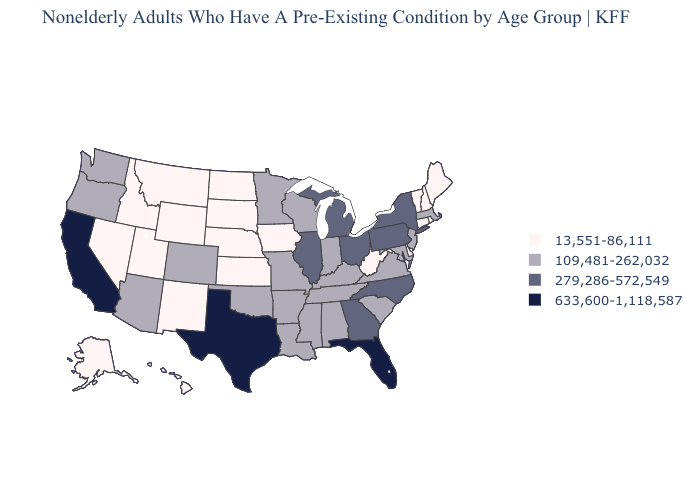Does Pennsylvania have the highest value in the Northeast?
Quick response, please. Yes. Does California have the lowest value in the West?
Answer briefly. No. Name the states that have a value in the range 633,600-1,118,587?
Be succinct. California, Florida, Texas. Does Arizona have a higher value than Mississippi?
Short answer required. No. Name the states that have a value in the range 13,551-86,111?
Keep it brief. Alaska, Connecticut, Delaware, Hawaii, Idaho, Iowa, Kansas, Maine, Montana, Nebraska, Nevada, New Hampshire, New Mexico, North Dakota, Rhode Island, South Dakota, Utah, Vermont, West Virginia, Wyoming. What is the value of Washington?
Answer briefly. 109,481-262,032. Which states hav the highest value in the MidWest?
Quick response, please. Illinois, Michigan, Ohio. What is the lowest value in the MidWest?
Give a very brief answer. 13,551-86,111. Does Florida have the highest value in the USA?
Give a very brief answer. Yes. Among the states that border West Virginia , which have the highest value?
Concise answer only. Ohio, Pennsylvania. Name the states that have a value in the range 633,600-1,118,587?
Answer briefly. California, Florida, Texas. What is the highest value in the MidWest ?
Give a very brief answer. 279,286-572,549. Name the states that have a value in the range 279,286-572,549?
Keep it brief. Georgia, Illinois, Michigan, New York, North Carolina, Ohio, Pennsylvania. Among the states that border North Carolina , does Virginia have the lowest value?
Short answer required. Yes. Does California have the highest value in the USA?
Give a very brief answer. Yes. 